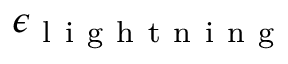<formula> <loc_0><loc_0><loc_500><loc_500>\epsilon _ { l i g h t n i n g }</formula> 